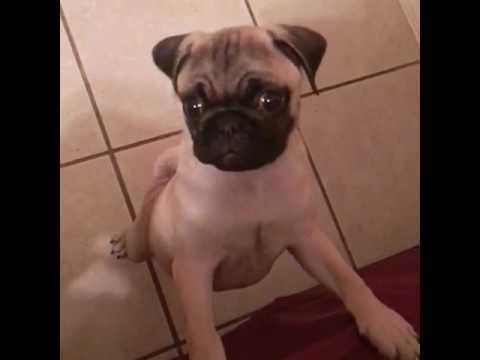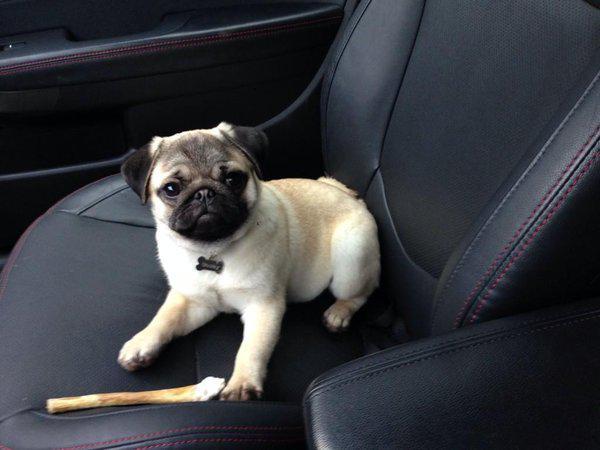The first image is the image on the left, the second image is the image on the right. Evaluate the accuracy of this statement regarding the images: "There is a single pug in each image.". Is it true? Answer yes or no. Yes. The first image is the image on the left, the second image is the image on the right. Given the left and right images, does the statement "There are at most two dogs." hold true? Answer yes or no. Yes. 